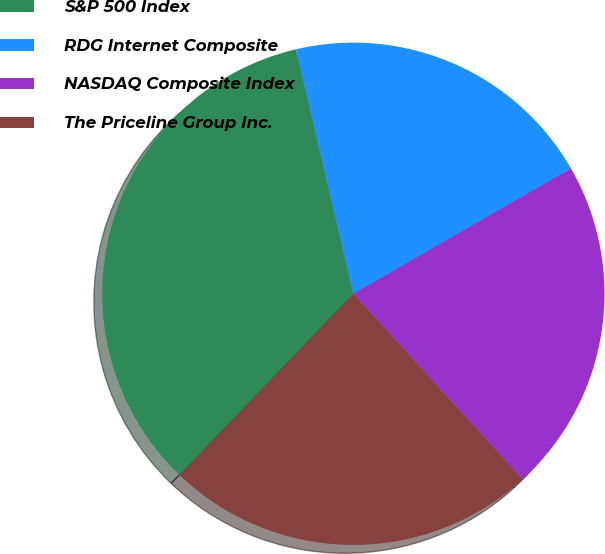Convert chart to OTSL. <chart><loc_0><loc_0><loc_500><loc_500><pie_chart><fcel>S&P 500 Index<fcel>RDG Internet Composite<fcel>NASDAQ Composite Index<fcel>The Priceline Group Inc.<nl><fcel>34.16%<fcel>20.35%<fcel>21.55%<fcel>23.94%<nl></chart> 